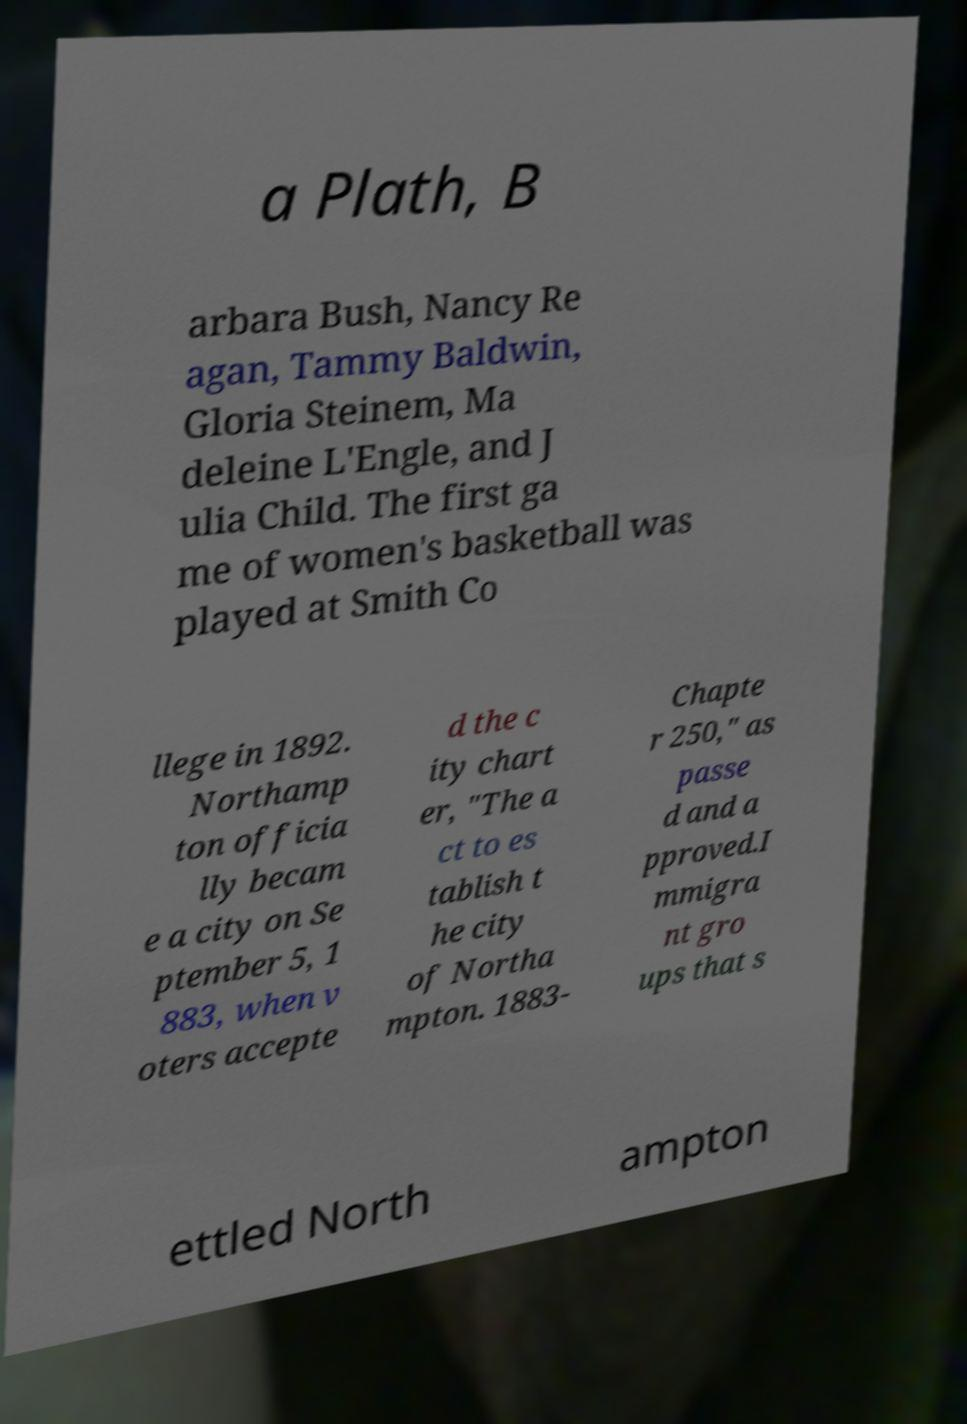Can you accurately transcribe the text from the provided image for me? a Plath, B arbara Bush, Nancy Re agan, Tammy Baldwin, Gloria Steinem, Ma deleine L'Engle, and J ulia Child. The first ga me of women's basketball was played at Smith Co llege in 1892. Northamp ton officia lly becam e a city on Se ptember 5, 1 883, when v oters accepte d the c ity chart er, "The a ct to es tablish t he city of Northa mpton. 1883- Chapte r 250," as passe d and a pproved.I mmigra nt gro ups that s ettled North ampton 